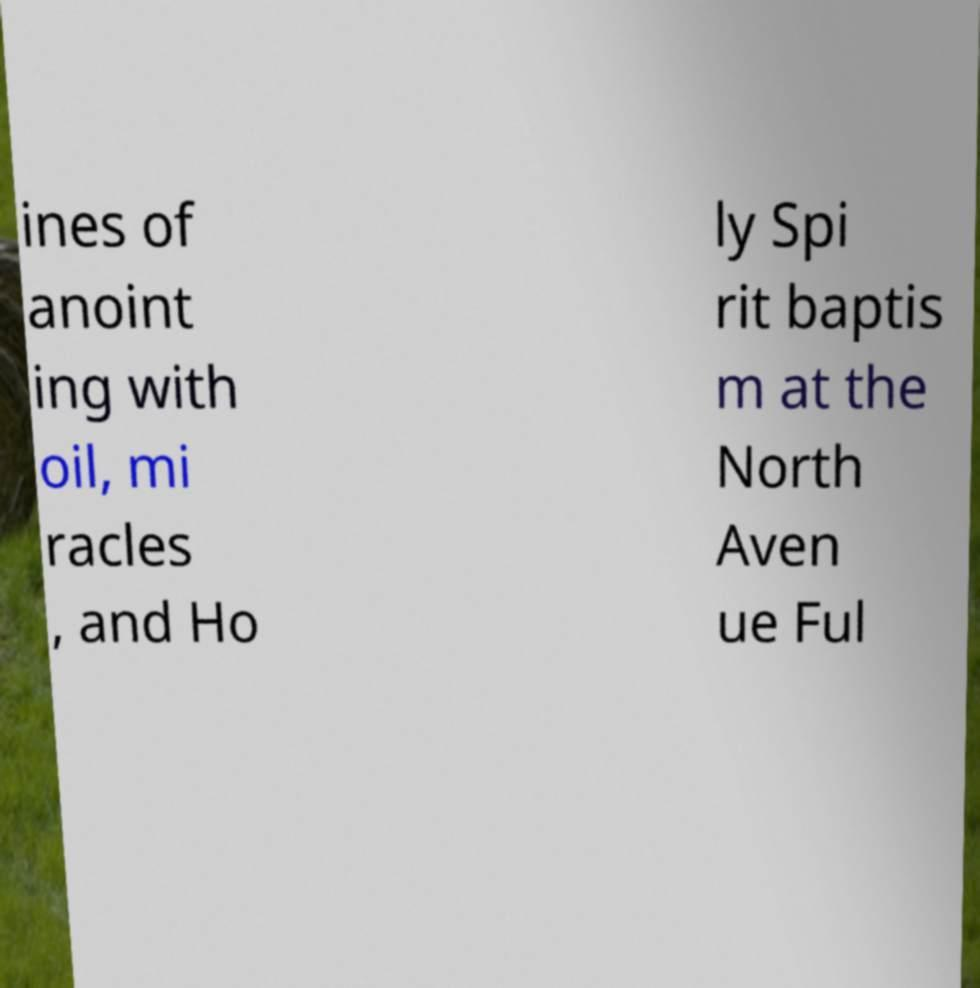I need the written content from this picture converted into text. Can you do that? ines of anoint ing with oil, mi racles , and Ho ly Spi rit baptis m at the North Aven ue Ful 